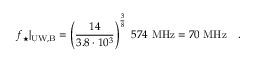Convert formula to latex. <formula><loc_0><loc_0><loc_500><loc_500>f _ { ^ { * } } | _ { U W , B } = \left ( { \frac { 1 4 } { 3 . 8 \cdot 1 0 ^ { 3 } } } \right ) ^ { \frac { 3 } { 8 } } 5 7 4 M H z = 7 0 M H z \ .</formula> 